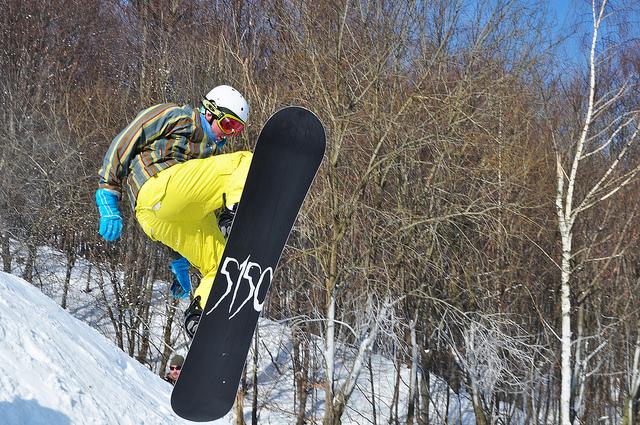What color is the person's pants?
Quick response, please. Yellow. Could the season be winter?
Write a very short answer. Yes. What number is on the bottom of the board?
Write a very short answer. 5150. 